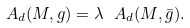<formula> <loc_0><loc_0><loc_500><loc_500>A _ { d } ( M , g ) = \lambda \ A _ { d } ( M , \bar { g } ) .</formula> 